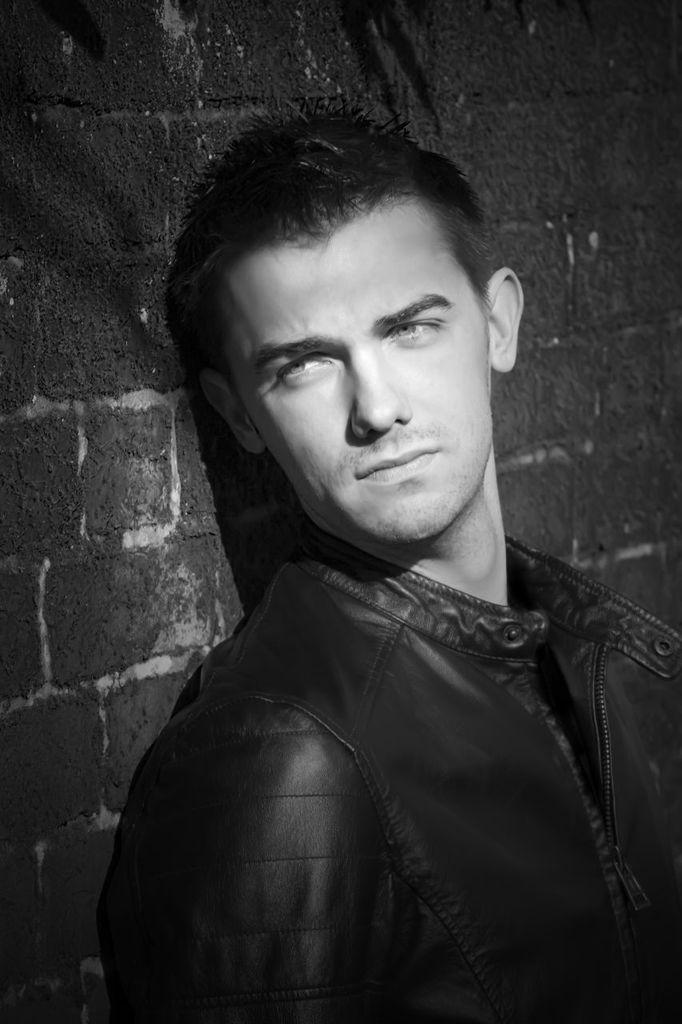What is the main subject of the image? The main subject of the image is a man standing. What type of structure is visible in the background of the image? There is a brick wall in the image. Can you see a gate in the image? There is no gate present in the image. Is the man playing a game of volleyball in the image? There is no indication of a volleyball game or any sports activity in the image. 